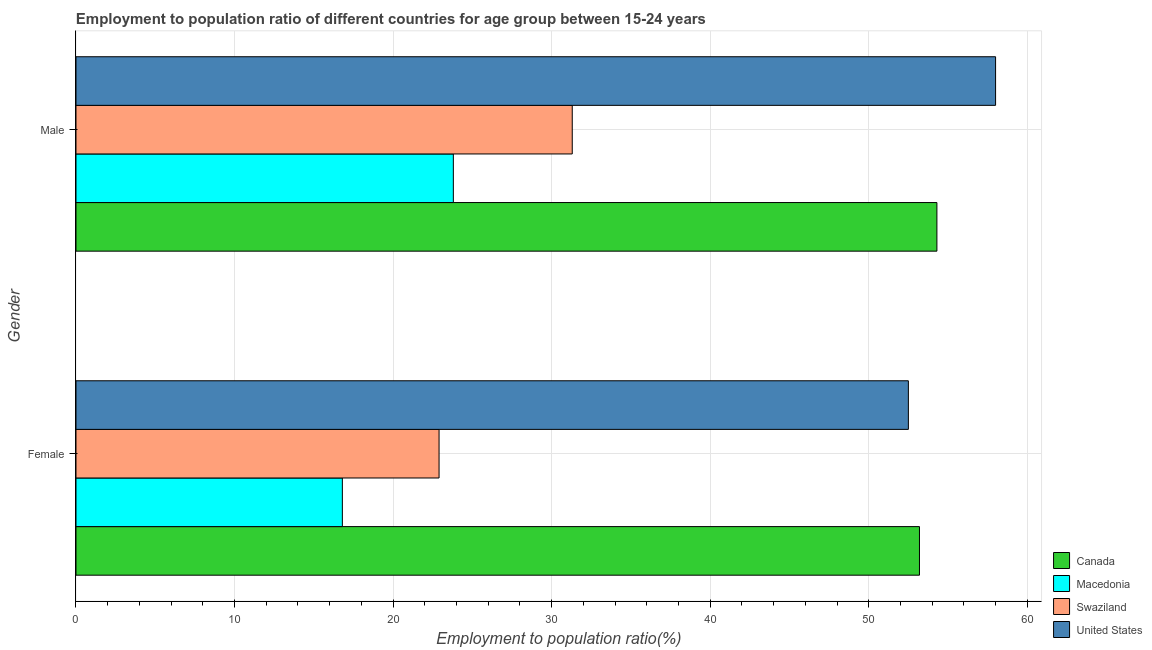How many groups of bars are there?
Ensure brevity in your answer.  2. How many bars are there on the 2nd tick from the bottom?
Your answer should be very brief. 4. What is the employment to population ratio(female) in Swaziland?
Provide a short and direct response. 22.9. Across all countries, what is the maximum employment to population ratio(female)?
Your response must be concise. 53.2. Across all countries, what is the minimum employment to population ratio(female)?
Offer a terse response. 16.8. In which country was the employment to population ratio(female) minimum?
Keep it short and to the point. Macedonia. What is the total employment to population ratio(male) in the graph?
Provide a succinct answer. 167.4. What is the difference between the employment to population ratio(male) in Canada and that in United States?
Provide a short and direct response. -3.7. What is the difference between the employment to population ratio(male) in Macedonia and the employment to population ratio(female) in Canada?
Make the answer very short. -29.4. What is the average employment to population ratio(female) per country?
Keep it short and to the point. 36.35. What is the difference between the employment to population ratio(male) and employment to population ratio(female) in Canada?
Offer a very short reply. 1.1. What is the ratio of the employment to population ratio(female) in Canada to that in United States?
Your answer should be compact. 1.01. Is the employment to population ratio(female) in Canada less than that in Macedonia?
Keep it short and to the point. No. In how many countries, is the employment to population ratio(female) greater than the average employment to population ratio(female) taken over all countries?
Provide a short and direct response. 2. What does the 2nd bar from the top in Female represents?
Make the answer very short. Swaziland. What does the 3rd bar from the bottom in Female represents?
Give a very brief answer. Swaziland. How many bars are there?
Ensure brevity in your answer.  8. Are all the bars in the graph horizontal?
Provide a succinct answer. Yes. Are the values on the major ticks of X-axis written in scientific E-notation?
Your answer should be very brief. No. Does the graph contain any zero values?
Your answer should be very brief. No. Does the graph contain grids?
Offer a terse response. Yes. Where does the legend appear in the graph?
Keep it short and to the point. Bottom right. How many legend labels are there?
Your response must be concise. 4. How are the legend labels stacked?
Ensure brevity in your answer.  Vertical. What is the title of the graph?
Give a very brief answer. Employment to population ratio of different countries for age group between 15-24 years. Does "Lithuania" appear as one of the legend labels in the graph?
Your response must be concise. No. What is the label or title of the Y-axis?
Make the answer very short. Gender. What is the Employment to population ratio(%) of Canada in Female?
Offer a terse response. 53.2. What is the Employment to population ratio(%) in Macedonia in Female?
Your answer should be very brief. 16.8. What is the Employment to population ratio(%) of Swaziland in Female?
Keep it short and to the point. 22.9. What is the Employment to population ratio(%) in United States in Female?
Provide a succinct answer. 52.5. What is the Employment to population ratio(%) of Canada in Male?
Provide a short and direct response. 54.3. What is the Employment to population ratio(%) in Macedonia in Male?
Your answer should be very brief. 23.8. What is the Employment to population ratio(%) of Swaziland in Male?
Your response must be concise. 31.3. Across all Gender, what is the maximum Employment to population ratio(%) of Canada?
Offer a terse response. 54.3. Across all Gender, what is the maximum Employment to population ratio(%) of Macedonia?
Make the answer very short. 23.8. Across all Gender, what is the maximum Employment to population ratio(%) of Swaziland?
Offer a very short reply. 31.3. Across all Gender, what is the maximum Employment to population ratio(%) of United States?
Ensure brevity in your answer.  58. Across all Gender, what is the minimum Employment to population ratio(%) of Canada?
Your response must be concise. 53.2. Across all Gender, what is the minimum Employment to population ratio(%) in Macedonia?
Give a very brief answer. 16.8. Across all Gender, what is the minimum Employment to population ratio(%) of Swaziland?
Give a very brief answer. 22.9. Across all Gender, what is the minimum Employment to population ratio(%) in United States?
Make the answer very short. 52.5. What is the total Employment to population ratio(%) in Canada in the graph?
Offer a very short reply. 107.5. What is the total Employment to population ratio(%) in Macedonia in the graph?
Offer a terse response. 40.6. What is the total Employment to population ratio(%) of Swaziland in the graph?
Your answer should be very brief. 54.2. What is the total Employment to population ratio(%) of United States in the graph?
Make the answer very short. 110.5. What is the difference between the Employment to population ratio(%) of Canada in Female and that in Male?
Make the answer very short. -1.1. What is the difference between the Employment to population ratio(%) in Macedonia in Female and that in Male?
Ensure brevity in your answer.  -7. What is the difference between the Employment to population ratio(%) in Swaziland in Female and that in Male?
Provide a succinct answer. -8.4. What is the difference between the Employment to population ratio(%) of Canada in Female and the Employment to population ratio(%) of Macedonia in Male?
Ensure brevity in your answer.  29.4. What is the difference between the Employment to population ratio(%) of Canada in Female and the Employment to population ratio(%) of Swaziland in Male?
Your answer should be very brief. 21.9. What is the difference between the Employment to population ratio(%) in Canada in Female and the Employment to population ratio(%) in United States in Male?
Ensure brevity in your answer.  -4.8. What is the difference between the Employment to population ratio(%) of Macedonia in Female and the Employment to population ratio(%) of United States in Male?
Provide a succinct answer. -41.2. What is the difference between the Employment to population ratio(%) in Swaziland in Female and the Employment to population ratio(%) in United States in Male?
Provide a succinct answer. -35.1. What is the average Employment to population ratio(%) of Canada per Gender?
Provide a succinct answer. 53.75. What is the average Employment to population ratio(%) in Macedonia per Gender?
Make the answer very short. 20.3. What is the average Employment to population ratio(%) of Swaziland per Gender?
Offer a very short reply. 27.1. What is the average Employment to population ratio(%) in United States per Gender?
Provide a succinct answer. 55.25. What is the difference between the Employment to population ratio(%) of Canada and Employment to population ratio(%) of Macedonia in Female?
Offer a terse response. 36.4. What is the difference between the Employment to population ratio(%) of Canada and Employment to population ratio(%) of Swaziland in Female?
Offer a very short reply. 30.3. What is the difference between the Employment to population ratio(%) of Canada and Employment to population ratio(%) of United States in Female?
Your answer should be compact. 0.7. What is the difference between the Employment to population ratio(%) in Macedonia and Employment to population ratio(%) in Swaziland in Female?
Give a very brief answer. -6.1. What is the difference between the Employment to population ratio(%) in Macedonia and Employment to population ratio(%) in United States in Female?
Your answer should be very brief. -35.7. What is the difference between the Employment to population ratio(%) of Swaziland and Employment to population ratio(%) of United States in Female?
Your answer should be compact. -29.6. What is the difference between the Employment to population ratio(%) in Canada and Employment to population ratio(%) in Macedonia in Male?
Provide a succinct answer. 30.5. What is the difference between the Employment to population ratio(%) in Canada and Employment to population ratio(%) in Swaziland in Male?
Make the answer very short. 23. What is the difference between the Employment to population ratio(%) in Macedonia and Employment to population ratio(%) in Swaziland in Male?
Provide a short and direct response. -7.5. What is the difference between the Employment to population ratio(%) in Macedonia and Employment to population ratio(%) in United States in Male?
Offer a terse response. -34.2. What is the difference between the Employment to population ratio(%) in Swaziland and Employment to population ratio(%) in United States in Male?
Keep it short and to the point. -26.7. What is the ratio of the Employment to population ratio(%) of Canada in Female to that in Male?
Make the answer very short. 0.98. What is the ratio of the Employment to population ratio(%) in Macedonia in Female to that in Male?
Your answer should be compact. 0.71. What is the ratio of the Employment to population ratio(%) of Swaziland in Female to that in Male?
Make the answer very short. 0.73. What is the ratio of the Employment to population ratio(%) of United States in Female to that in Male?
Make the answer very short. 0.91. What is the difference between the highest and the second highest Employment to population ratio(%) in Canada?
Provide a succinct answer. 1.1. What is the difference between the highest and the second highest Employment to population ratio(%) in Swaziland?
Your answer should be compact. 8.4. What is the difference between the highest and the lowest Employment to population ratio(%) of Canada?
Your answer should be very brief. 1.1. What is the difference between the highest and the lowest Employment to population ratio(%) in Macedonia?
Provide a short and direct response. 7. What is the difference between the highest and the lowest Employment to population ratio(%) of Swaziland?
Offer a terse response. 8.4. 